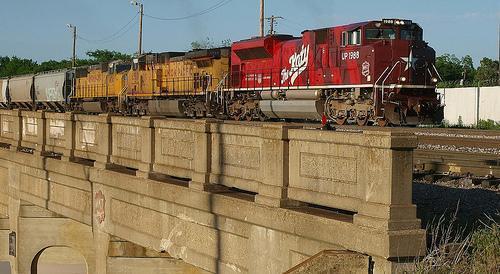How many trains are in the photo?
Give a very brief answer. 1. 